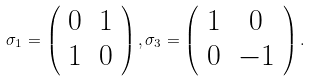Convert formula to latex. <formula><loc_0><loc_0><loc_500><loc_500>\sigma _ { 1 } = \left ( \begin{array} { c c } { 0 } & { 1 } \\ { 1 } & { 0 } \end{array} \right ) , \sigma _ { 3 } = \left ( \begin{array} { c c } { 1 } & { 0 } \\ { 0 } & { - 1 } \end{array} \right ) .</formula> 